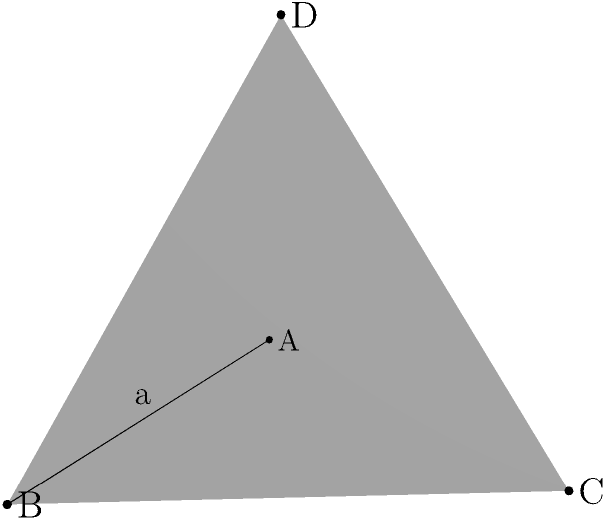In your analysis of Woody Allen's film "Manhattan" (1979), you notice a scene where the protagonist, Isaac Davis, discusses geometry with his young girlfriend, Tracy. To illustrate the concept of volume, you decide to use a tetrahedron as an example. Given a regular tetrahedron ABCD with edge length $a = 6$ cm, calculate its volume. How might this geometric discussion relate to the film's portrayal of age differences in relationships? To calculate the volume of a regular tetrahedron given its edge length, we can follow these steps:

1) The formula for the volume of a regular tetrahedron is:

   $$V = \frac{\sqrt{2}}{12}a^3$$

   Where $a$ is the length of an edge.

2) We are given that $a = 6$ cm. Let's substitute this into our formula:

   $$V = \frac{\sqrt{2}}{12}(6)^3$$

3) Simplify the cube:

   $$V = \frac{\sqrt{2}}{12}(216)$$

4) Multiply:

   $$V = 18\sqrt{2}$$

5) This can be simplified to:

   $$V = 9\sqrt{8} \approx 25.46 \text{ cm}^3$$

Relating to the film: This geometric discussion could symbolize the complexity and multifaceted nature of relationships in Allen's films, particularly those with significant age differences. The tetrahedron, with its four faces, might represent different perspectives or dimensions of these relationships, while the calculation of its volume could metaphorically represent an attempt to quantify or understand the depth and substance of these connections.
Answer: $9\sqrt{8} \text{ cm}^3$ 